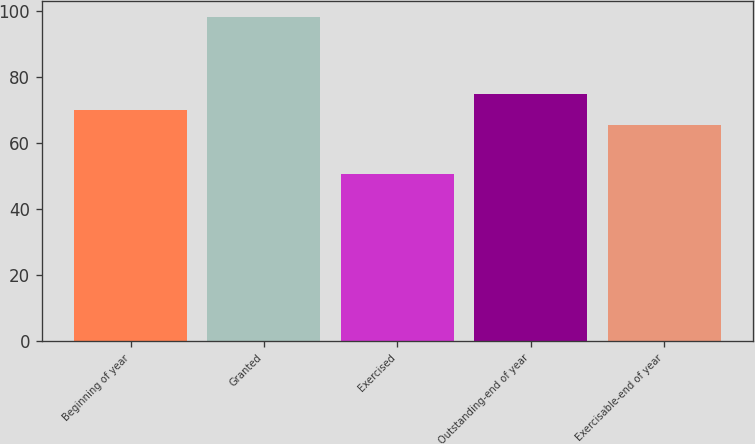Convert chart. <chart><loc_0><loc_0><loc_500><loc_500><bar_chart><fcel>Beginning of year<fcel>Granted<fcel>Exercised<fcel>Outstanding-end of year<fcel>Exercisable-end of year<nl><fcel>70.08<fcel>98.07<fcel>50.63<fcel>74.82<fcel>65.34<nl></chart> 